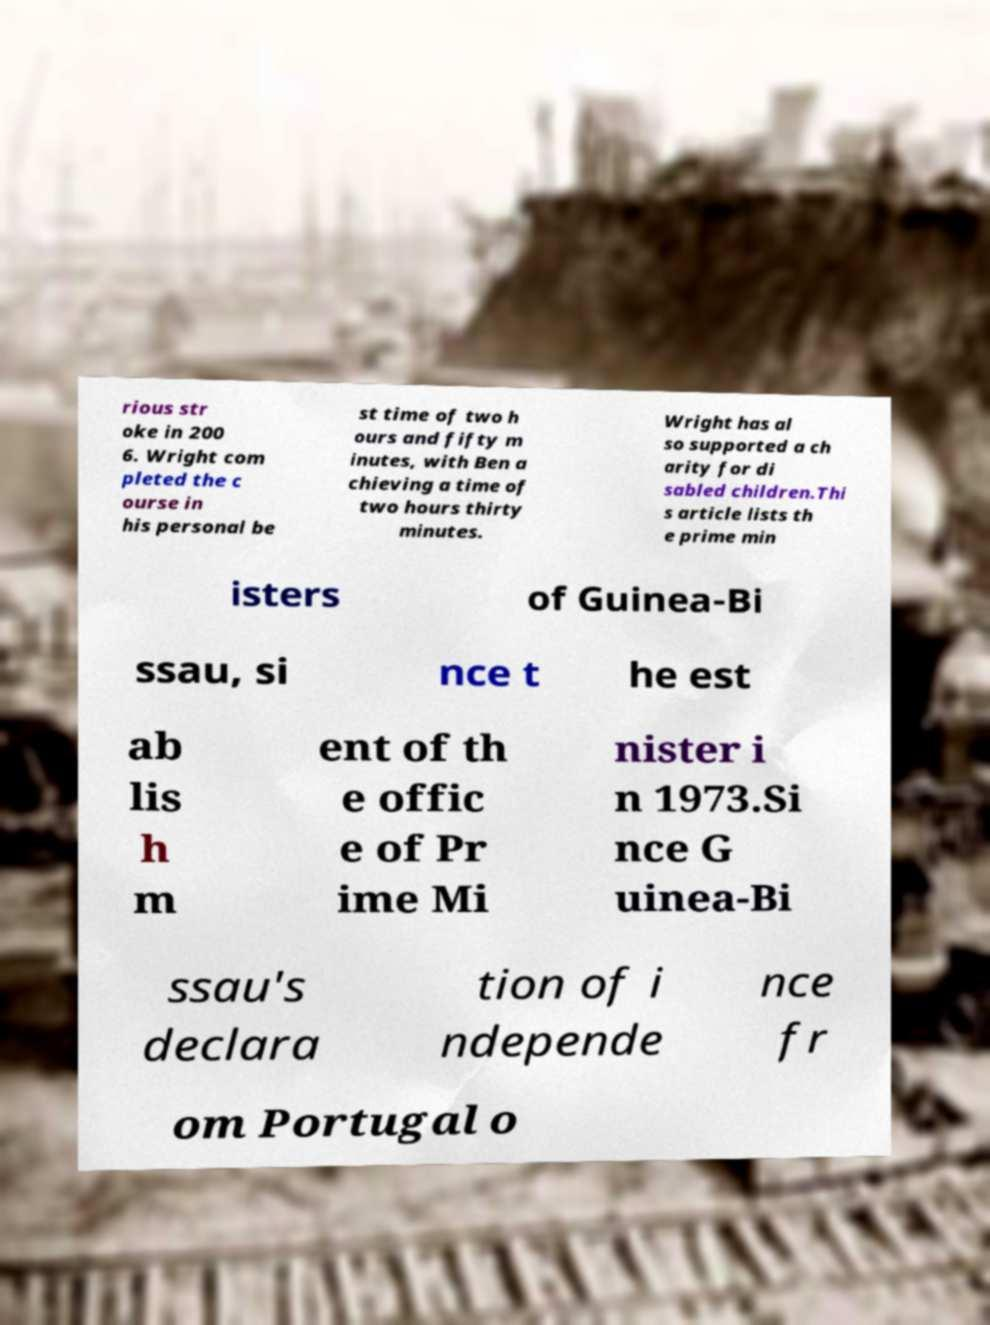Can you read and provide the text displayed in the image?This photo seems to have some interesting text. Can you extract and type it out for me? rious str oke in 200 6. Wright com pleted the c ourse in his personal be st time of two h ours and fifty m inutes, with Ben a chieving a time of two hours thirty minutes. Wright has al so supported a ch arity for di sabled children.Thi s article lists th e prime min isters of Guinea-Bi ssau, si nce t he est ab lis h m ent of th e offic e of Pr ime Mi nister i n 1973.Si nce G uinea-Bi ssau's declara tion of i ndepende nce fr om Portugal o 